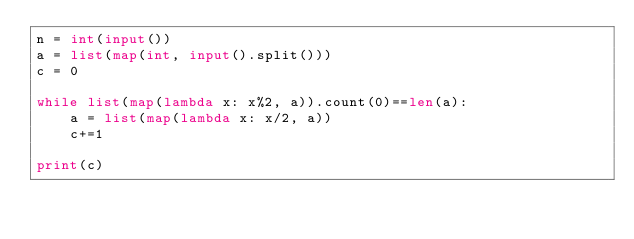<code> <loc_0><loc_0><loc_500><loc_500><_Python_>n = int(input())
a = list(map(int, input().split()))
c = 0

while list(map(lambda x: x%2, a)).count(0)==len(a):
    a = list(map(lambda x: x/2, a))
    c+=1

print(c)
</code> 